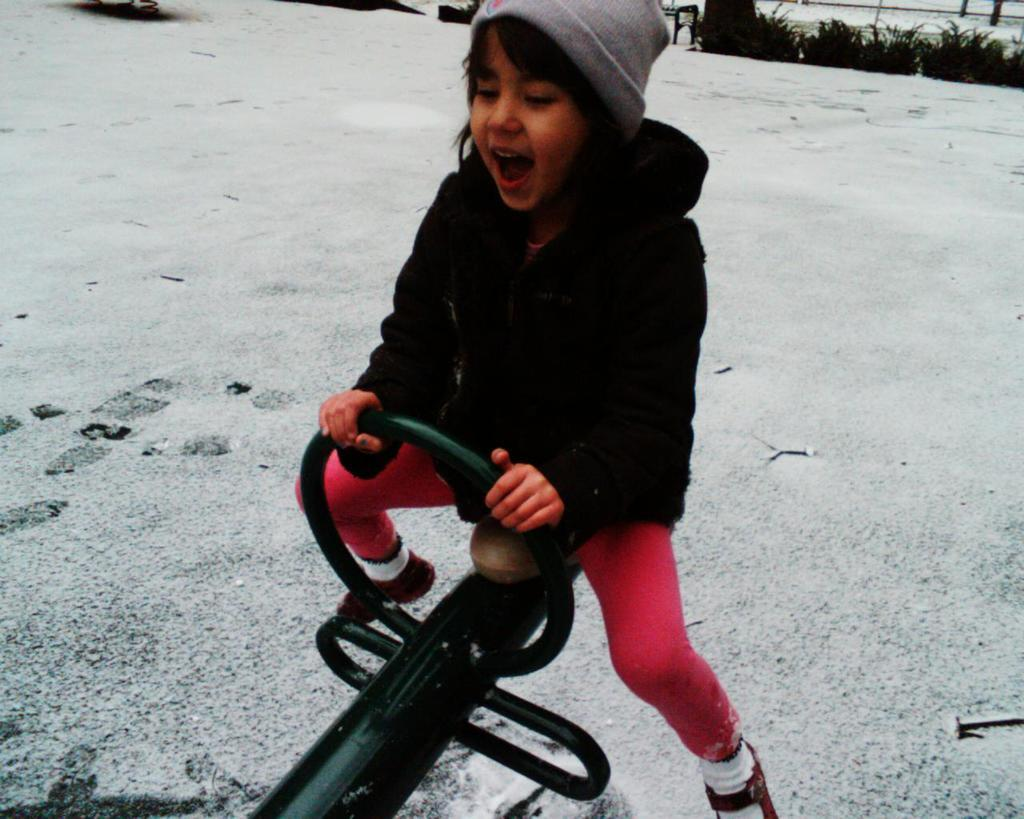Who is the main subject in the picture? There is a girl in the picture. What is the girl wearing in the picture? The girl is wearing a jacket and a cap. What is the girl doing in the picture? The girl is sitting on a seesaw. What can be seen in the background of the picture? There is snow and trees in the background of the picture. What type of secretary is present in the image? There is no secretary present in the image; it features a girl sitting on a seesaw in the snow. 